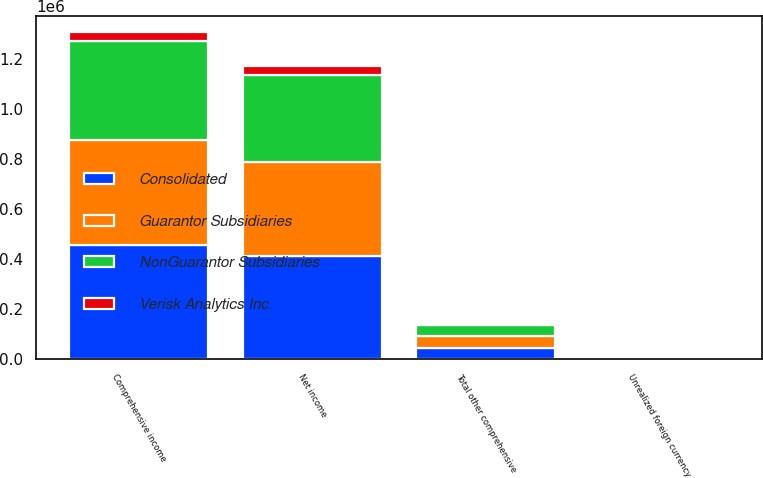<chart> <loc_0><loc_0><loc_500><loc_500><stacked_bar_chart><ecel><fcel>Net income<fcel>Unrealized foreign currency<fcel>Total other comprehensive<fcel>Comprehensive income<nl><fcel>NonGuarantor Subsidiaries<fcel>348380<fcel>840<fcel>45672<fcel>394052<nl><fcel>Guarantor Subsidiaries<fcel>375026<fcel>778<fcel>45734<fcel>420760<nl><fcel>Verisk Analytics Inc.<fcel>37080<fcel>99<fcel>99<fcel>36981<nl><fcel>Consolidated<fcel>412106<fcel>877<fcel>45635<fcel>457741<nl></chart> 